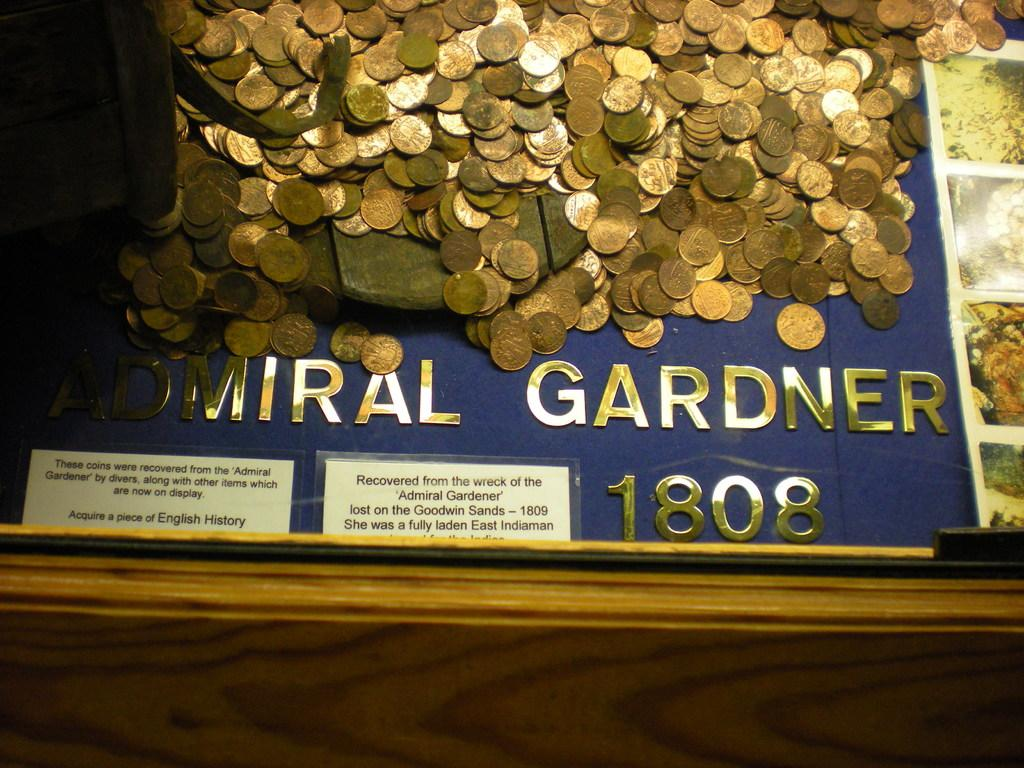Provide a one-sentence caption for the provided image. A lots of gold coins with 1808 at the bottom of the display. 